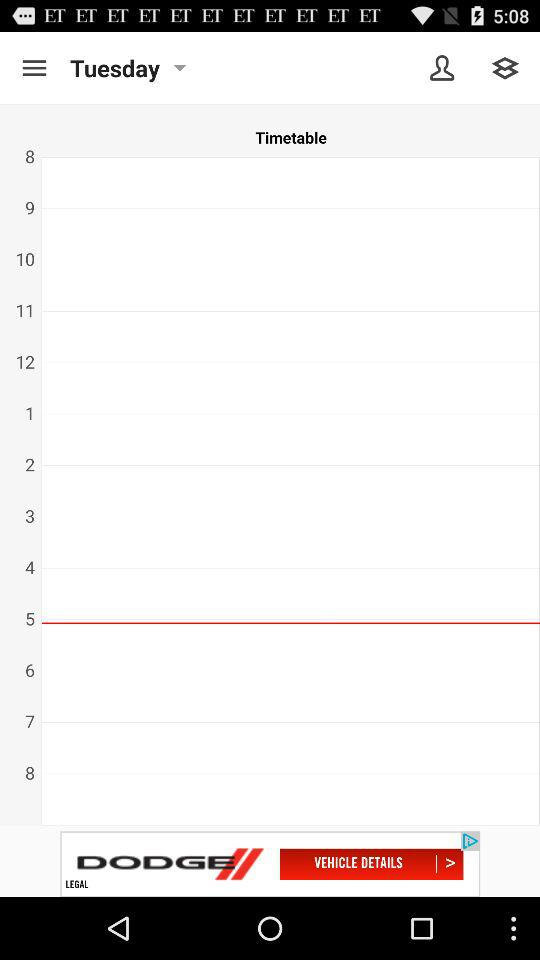Which day is it on the screen? The day is Tuesday. 